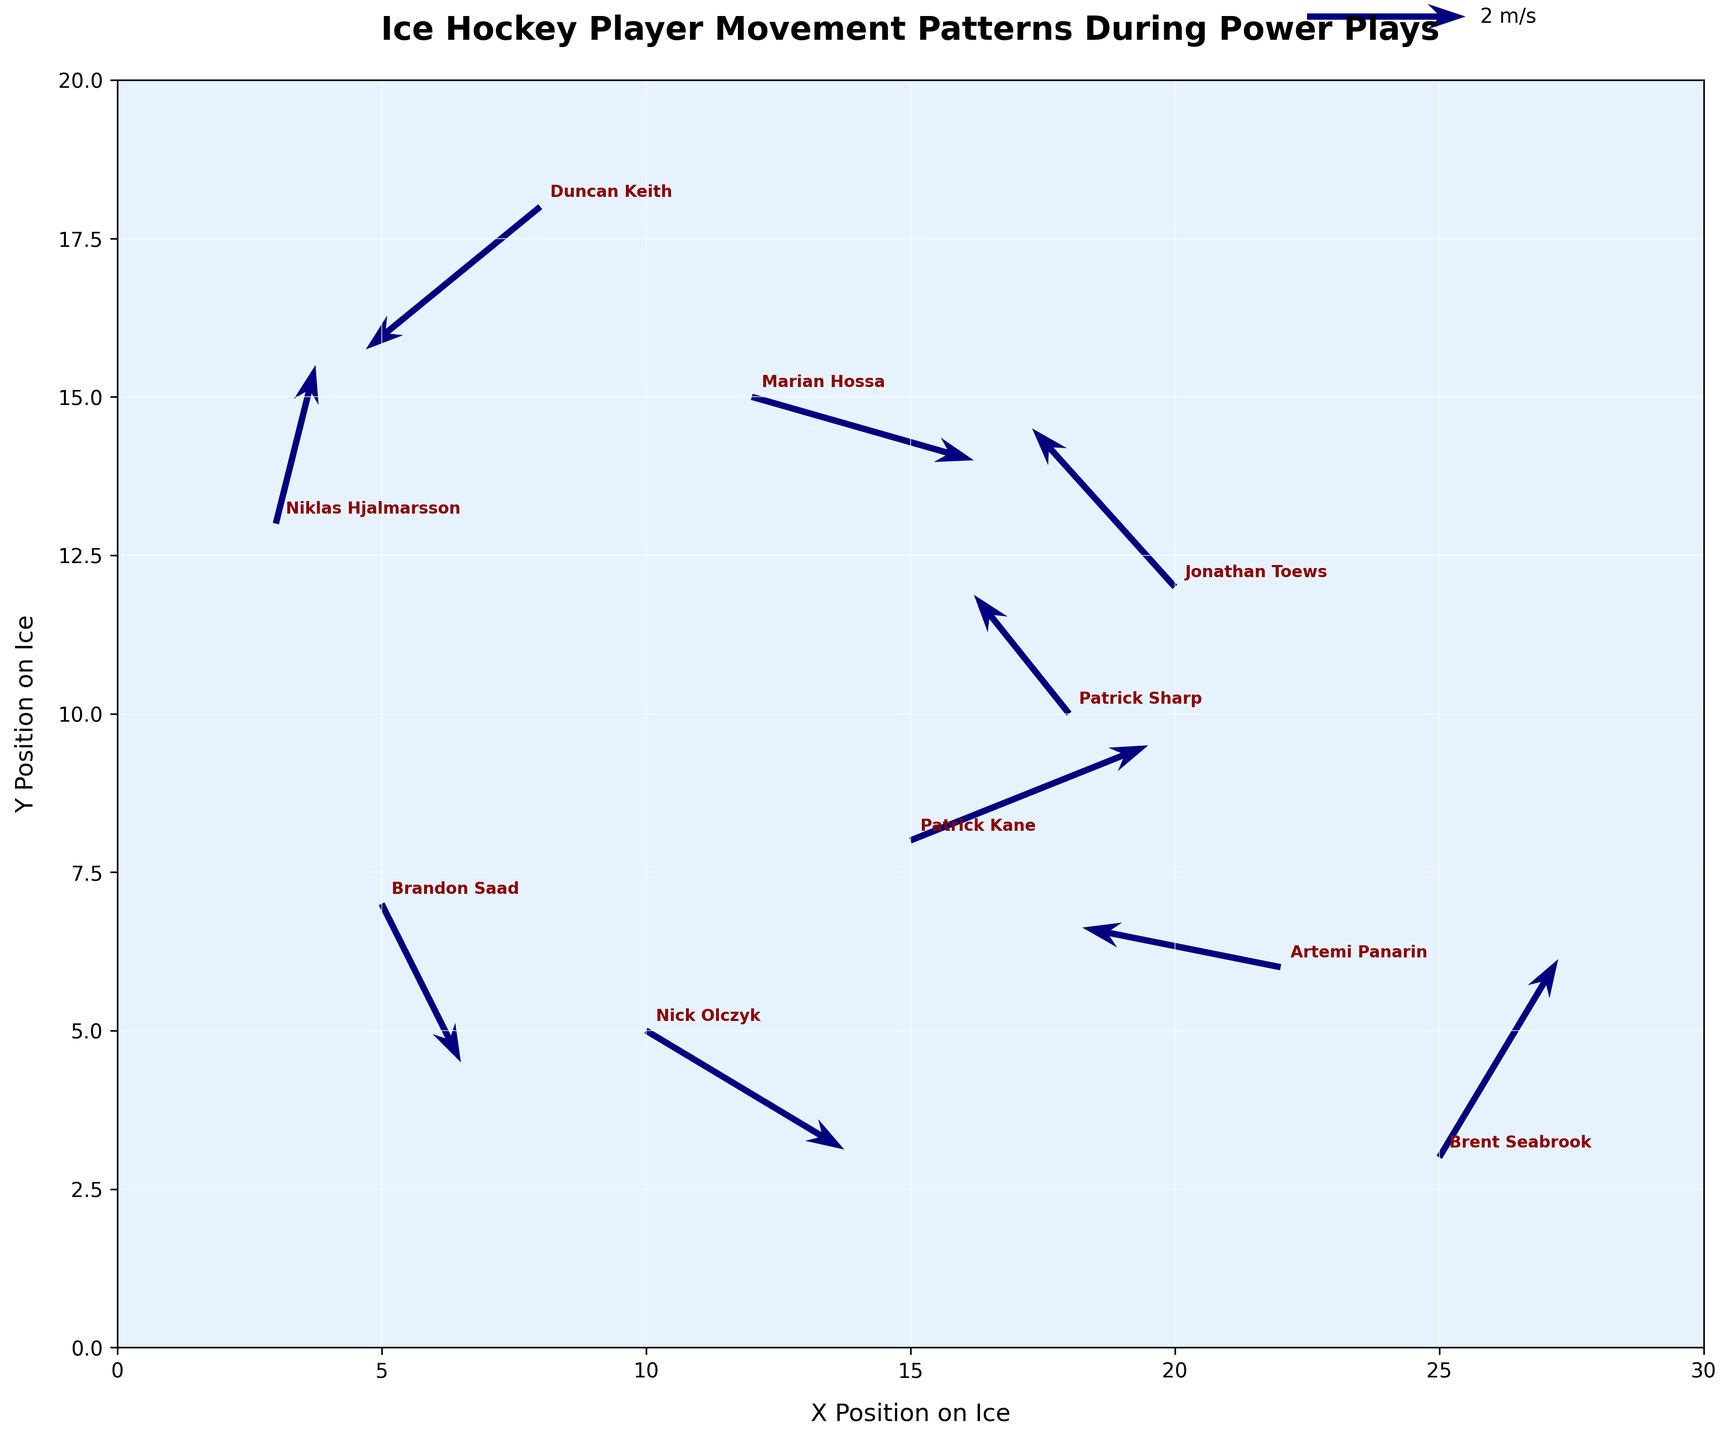What is the title of the figure? The title is located at the top of the figure. It is centered and in bold, making it easy to identify.
Answer: Ice Hockey Player Movement Patterns During Power Plays What are the labels for the X and Y axes? The X and Y axes labels are found near the horizontal and vertical axes respectively. These labels describe the position on the ice.
Answer: X Position on Ice, Y Position on Ice How many players’ movement patterns are shown on the quiver plot? Each player is annotated by name next to a quiver arrow, making it easy to count the total number of players. By inspecting the figure, we count the number of distinct annotations (player names).
Answer: 10 Which player has the highest X position on the ice? By examining the X-axis positions of all players annotated with their names, one can identify which annotation appears farthest to the right.
Answer: Brent Seabrook Which player has the lowest Y position on the ice? By examining the Y-axis positions of all players annotated with their names, one can identify which annotation is lowest on the plot.
Answer: Brent Seabrook What direction is the movement of Duncan Keith? The direction can be inferred by looking at the angle of the vector (arrow) associated with Duncan Keith, pointing towards (8-2.2, 18-1.8).
Answer: South-West What is the average X position of Niklas Hjalmarsson and Marian Hossa? To find the average X position, add the X positions of Niklas Hjalmarsson (3) and Marian Hossa (12), then divide by 2: (3 + 12) / 2 = 7.5
Answer: 7.5 Which player has the highest movement speed? The speed of each player can be calculated using the Pythagorean theorem (√(u^2 + v^2)). The player with the largest calculated speed value is the answer.
Answer: Brent Seabrook Are there any players moving directly vertically? Look at the arrows and their components (u, v). If u = 0 and v is non-zero, the player is moving vertically. Check each annotation to see if any match this criteria.
Answer: No Which player is moving in the opposite direction of Jonathan Toews? Determine the direction of Jonathan Toews' movement (North-West) and then look for any player moving in the opposite direction (South-East).
Answer: Duncan Keith 